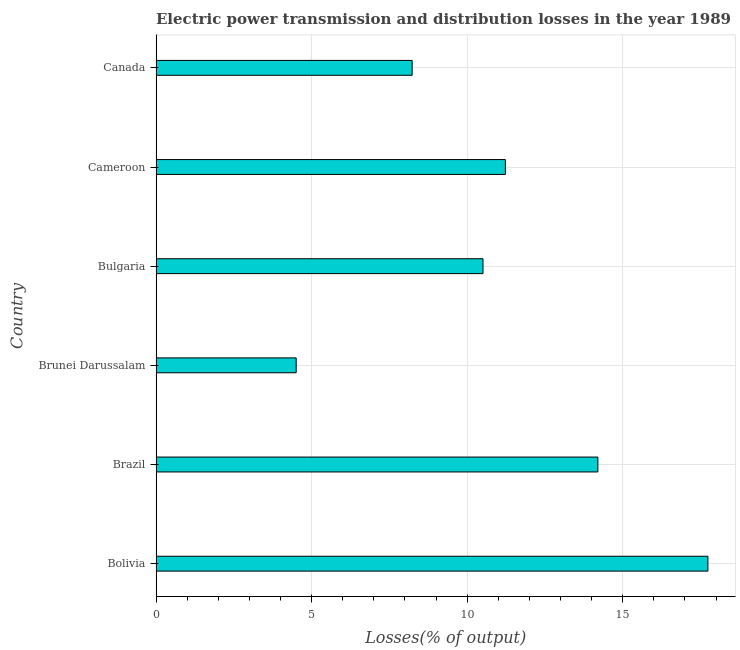Does the graph contain grids?
Your answer should be compact. Yes. What is the title of the graph?
Offer a terse response. Electric power transmission and distribution losses in the year 1989. What is the label or title of the X-axis?
Keep it short and to the point. Losses(% of output). What is the electric power transmission and distribution losses in Bulgaria?
Provide a succinct answer. 10.51. Across all countries, what is the maximum electric power transmission and distribution losses?
Your answer should be compact. 17.74. Across all countries, what is the minimum electric power transmission and distribution losses?
Give a very brief answer. 4.51. In which country was the electric power transmission and distribution losses minimum?
Give a very brief answer. Brunei Darussalam. What is the sum of the electric power transmission and distribution losses?
Give a very brief answer. 66.42. What is the difference between the electric power transmission and distribution losses in Brunei Darussalam and Bulgaria?
Provide a succinct answer. -6. What is the average electric power transmission and distribution losses per country?
Your response must be concise. 11.07. What is the median electric power transmission and distribution losses?
Offer a very short reply. 10.87. In how many countries, is the electric power transmission and distribution losses greater than 11 %?
Give a very brief answer. 3. What is the ratio of the electric power transmission and distribution losses in Brazil to that in Brunei Darussalam?
Your response must be concise. 3.15. What is the difference between the highest and the second highest electric power transmission and distribution losses?
Ensure brevity in your answer.  3.54. Is the sum of the electric power transmission and distribution losses in Brunei Darussalam and Cameroon greater than the maximum electric power transmission and distribution losses across all countries?
Your response must be concise. No. What is the difference between the highest and the lowest electric power transmission and distribution losses?
Your answer should be compact. 13.23. Are all the bars in the graph horizontal?
Give a very brief answer. Yes. Are the values on the major ticks of X-axis written in scientific E-notation?
Provide a short and direct response. No. What is the Losses(% of output) in Bolivia?
Provide a short and direct response. 17.74. What is the Losses(% of output) of Brazil?
Provide a short and direct response. 14.2. What is the Losses(% of output) of Brunei Darussalam?
Give a very brief answer. 4.51. What is the Losses(% of output) in Bulgaria?
Provide a succinct answer. 10.51. What is the Losses(% of output) in Cameroon?
Your answer should be compact. 11.23. What is the Losses(% of output) of Canada?
Your answer should be very brief. 8.23. What is the difference between the Losses(% of output) in Bolivia and Brazil?
Your response must be concise. 3.54. What is the difference between the Losses(% of output) in Bolivia and Brunei Darussalam?
Your answer should be compact. 13.23. What is the difference between the Losses(% of output) in Bolivia and Bulgaria?
Keep it short and to the point. 7.23. What is the difference between the Losses(% of output) in Bolivia and Cameroon?
Offer a terse response. 6.51. What is the difference between the Losses(% of output) in Bolivia and Canada?
Your answer should be compact. 9.51. What is the difference between the Losses(% of output) in Brazil and Brunei Darussalam?
Provide a short and direct response. 9.7. What is the difference between the Losses(% of output) in Brazil and Bulgaria?
Give a very brief answer. 3.69. What is the difference between the Losses(% of output) in Brazil and Cameroon?
Your answer should be compact. 2.97. What is the difference between the Losses(% of output) in Brazil and Canada?
Your response must be concise. 5.97. What is the difference between the Losses(% of output) in Brunei Darussalam and Bulgaria?
Your answer should be very brief. -6. What is the difference between the Losses(% of output) in Brunei Darussalam and Cameroon?
Offer a very short reply. -6.72. What is the difference between the Losses(% of output) in Brunei Darussalam and Canada?
Your response must be concise. -3.73. What is the difference between the Losses(% of output) in Bulgaria and Cameroon?
Make the answer very short. -0.72. What is the difference between the Losses(% of output) in Bulgaria and Canada?
Offer a terse response. 2.28. What is the difference between the Losses(% of output) in Cameroon and Canada?
Ensure brevity in your answer.  3. What is the ratio of the Losses(% of output) in Bolivia to that in Brazil?
Ensure brevity in your answer.  1.25. What is the ratio of the Losses(% of output) in Bolivia to that in Brunei Darussalam?
Your answer should be compact. 3.94. What is the ratio of the Losses(% of output) in Bolivia to that in Bulgaria?
Keep it short and to the point. 1.69. What is the ratio of the Losses(% of output) in Bolivia to that in Cameroon?
Your answer should be very brief. 1.58. What is the ratio of the Losses(% of output) in Bolivia to that in Canada?
Give a very brief answer. 2.15. What is the ratio of the Losses(% of output) in Brazil to that in Brunei Darussalam?
Your answer should be very brief. 3.15. What is the ratio of the Losses(% of output) in Brazil to that in Bulgaria?
Offer a very short reply. 1.35. What is the ratio of the Losses(% of output) in Brazil to that in Cameroon?
Offer a terse response. 1.26. What is the ratio of the Losses(% of output) in Brazil to that in Canada?
Offer a very short reply. 1.73. What is the ratio of the Losses(% of output) in Brunei Darussalam to that in Bulgaria?
Provide a short and direct response. 0.43. What is the ratio of the Losses(% of output) in Brunei Darussalam to that in Cameroon?
Provide a short and direct response. 0.4. What is the ratio of the Losses(% of output) in Brunei Darussalam to that in Canada?
Ensure brevity in your answer.  0.55. What is the ratio of the Losses(% of output) in Bulgaria to that in Cameroon?
Offer a terse response. 0.94. What is the ratio of the Losses(% of output) in Bulgaria to that in Canada?
Offer a very short reply. 1.28. What is the ratio of the Losses(% of output) in Cameroon to that in Canada?
Provide a short and direct response. 1.36. 